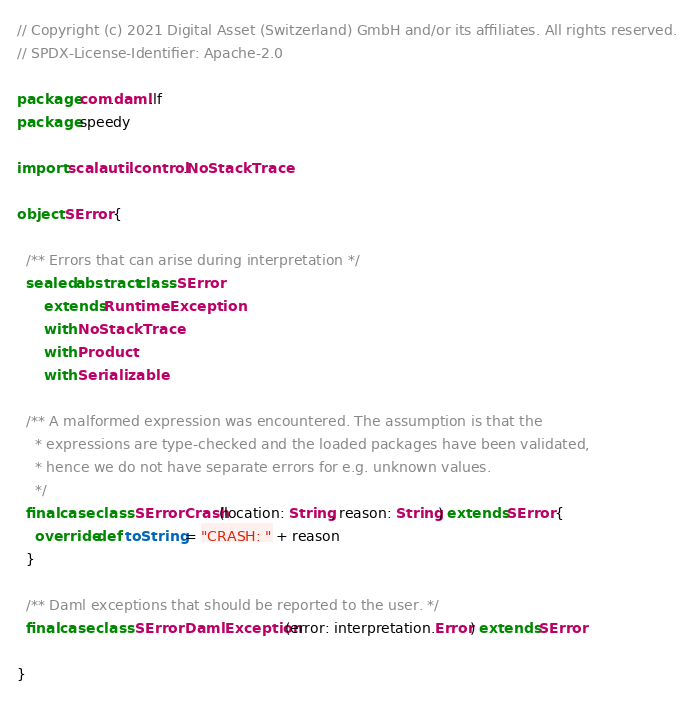Convert code to text. <code><loc_0><loc_0><loc_500><loc_500><_Scala_>// Copyright (c) 2021 Digital Asset (Switzerland) GmbH and/or its affiliates. All rights reserved.
// SPDX-License-Identifier: Apache-2.0

package com.daml.lf
package speedy

import scala.util.control.NoStackTrace

object SError {

  /** Errors that can arise during interpretation */
  sealed abstract class SError
      extends RuntimeException
      with NoStackTrace
      with Product
      with Serializable

  /** A malformed expression was encountered. The assumption is that the
    * expressions are type-checked and the loaded packages have been validated,
    * hence we do not have separate errors for e.g. unknown values.
    */
  final case class SErrorCrash(location: String, reason: String) extends SError {
    override def toString = "CRASH: " + reason
  }

  /** Daml exceptions that should be reported to the user. */
  final case class SErrorDamlException(error: interpretation.Error) extends SError

}
</code> 